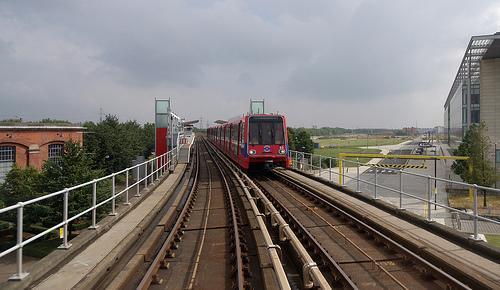How many trains are there?
Give a very brief answer. 1. How many sets of train tracks are there?
Give a very brief answer. 2. 